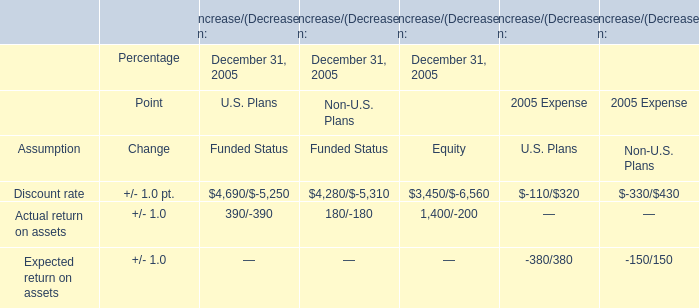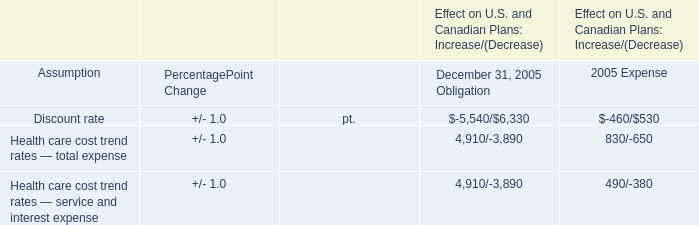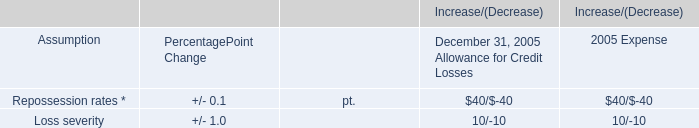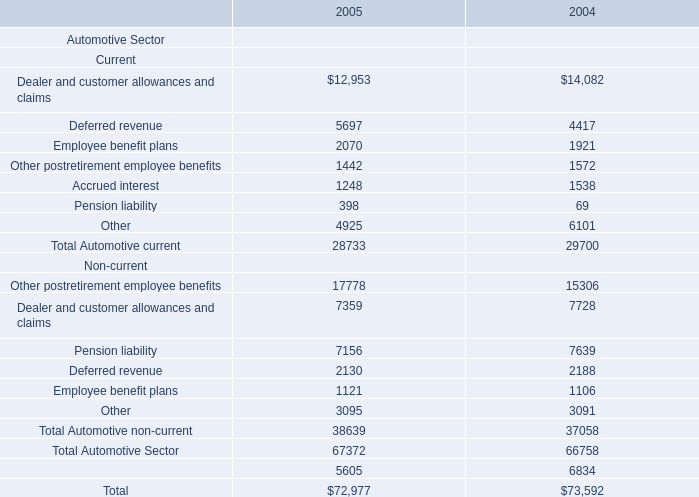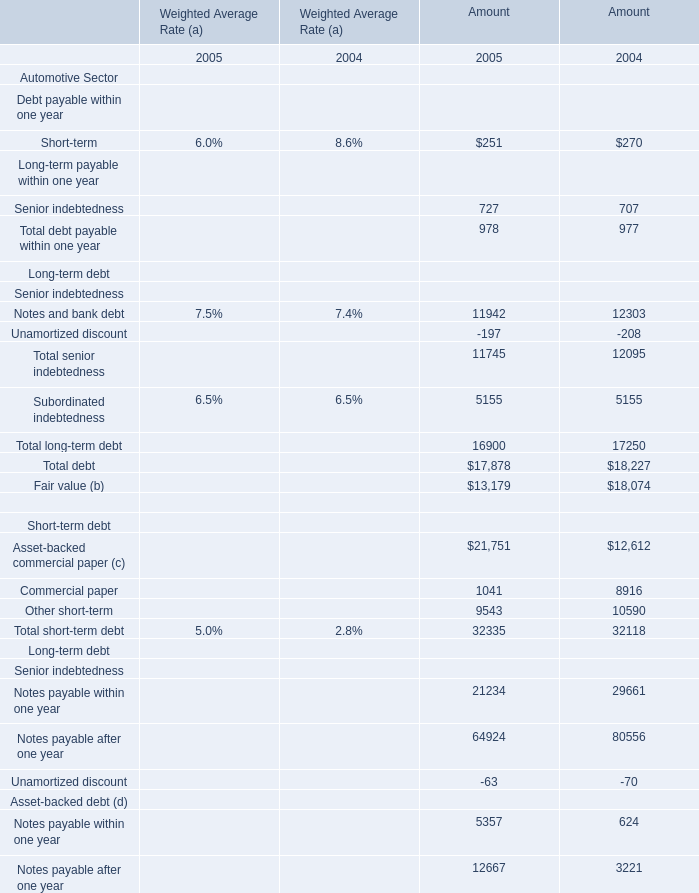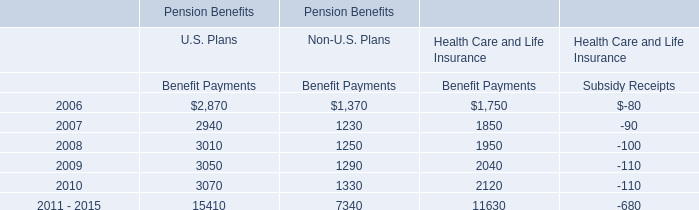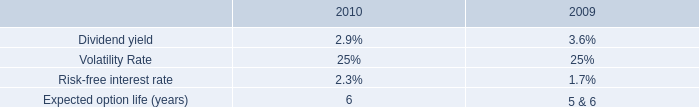What was the total amount of the Long-term payable within one year:Senior indebtedness in the years where Debt payable within one year:Short-term greater than 0 for Amount? 
Computations: (727 + 707)
Answer: 1434.0. 